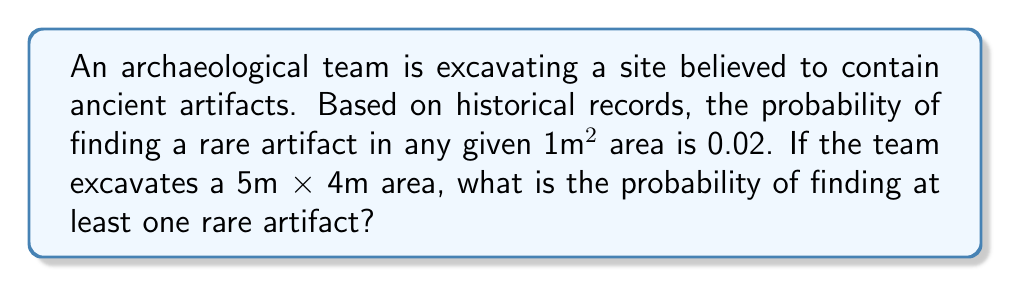Help me with this question. Let's approach this step-by-step:

1) First, we need to calculate the total area being excavated:
   Area = 5m × 4m = 20m²

2) The probability of finding a rare artifact in a 1m² area is 0.02.

3) We can calculate the probability of not finding a rare artifact in a 1m² area:
   $P(\text{no artifact in 1m²}) = 1 - 0.02 = 0.98$

4) For the entire 20m² area, we need to find the probability of not finding any artifacts in any of the 20 squares. This is equivalent to not finding an artifact 20 times in a row:
   $P(\text{no artifacts in 20m²}) = (0.98)^{20}$

5) We can calculate this:
   $(0.98)^{20} \approx 0.6676$

6) The probability we're looking for is the opposite of finding no artifacts. So we subtract this value from 1:
   $P(\text{at least one artifact}) = 1 - (0.98)^{20}$

7) Calculating:
   $1 - 0.6676 \approx 0.3324$

Therefore, the probability of finding at least one rare artifact in the 5m × 4m area is approximately 0.3324 or 33.24%.
Answer: $1 - (0.98)^{20} \approx 0.3324$ 